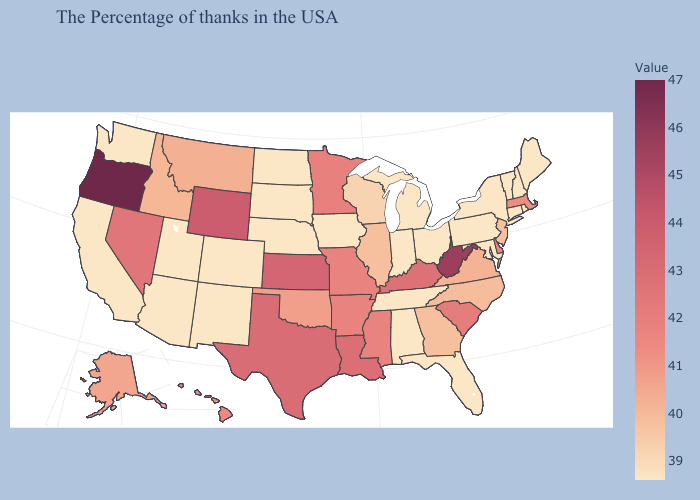Which states have the highest value in the USA?
Be succinct. Oregon. Does Maine have a lower value than Montana?
Be succinct. Yes. Does the map have missing data?
Answer briefly. No. Among the states that border Kansas , which have the highest value?
Keep it brief. Missouri. Which states have the highest value in the USA?
Give a very brief answer. Oregon. Among the states that border Missouri , which have the highest value?
Give a very brief answer. Kansas. 